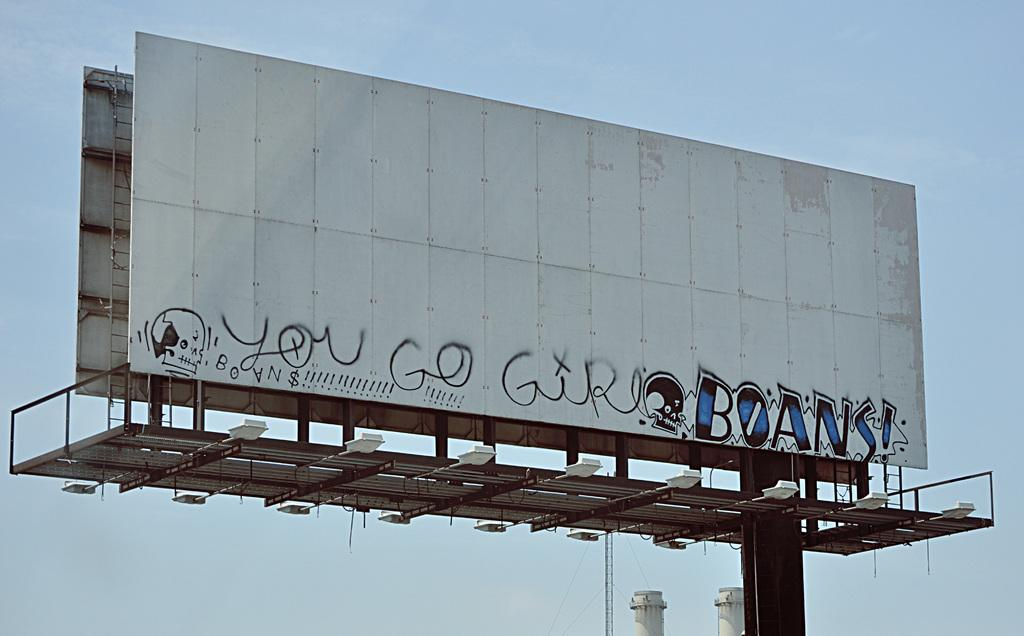Provide a one-sentence caption for the provided image. Graffiti scribbled on an empty billboard saying "you go". 